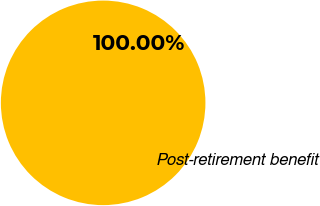Convert chart. <chart><loc_0><loc_0><loc_500><loc_500><pie_chart><fcel>Post-retirement benefit<nl><fcel>100.0%<nl></chart> 